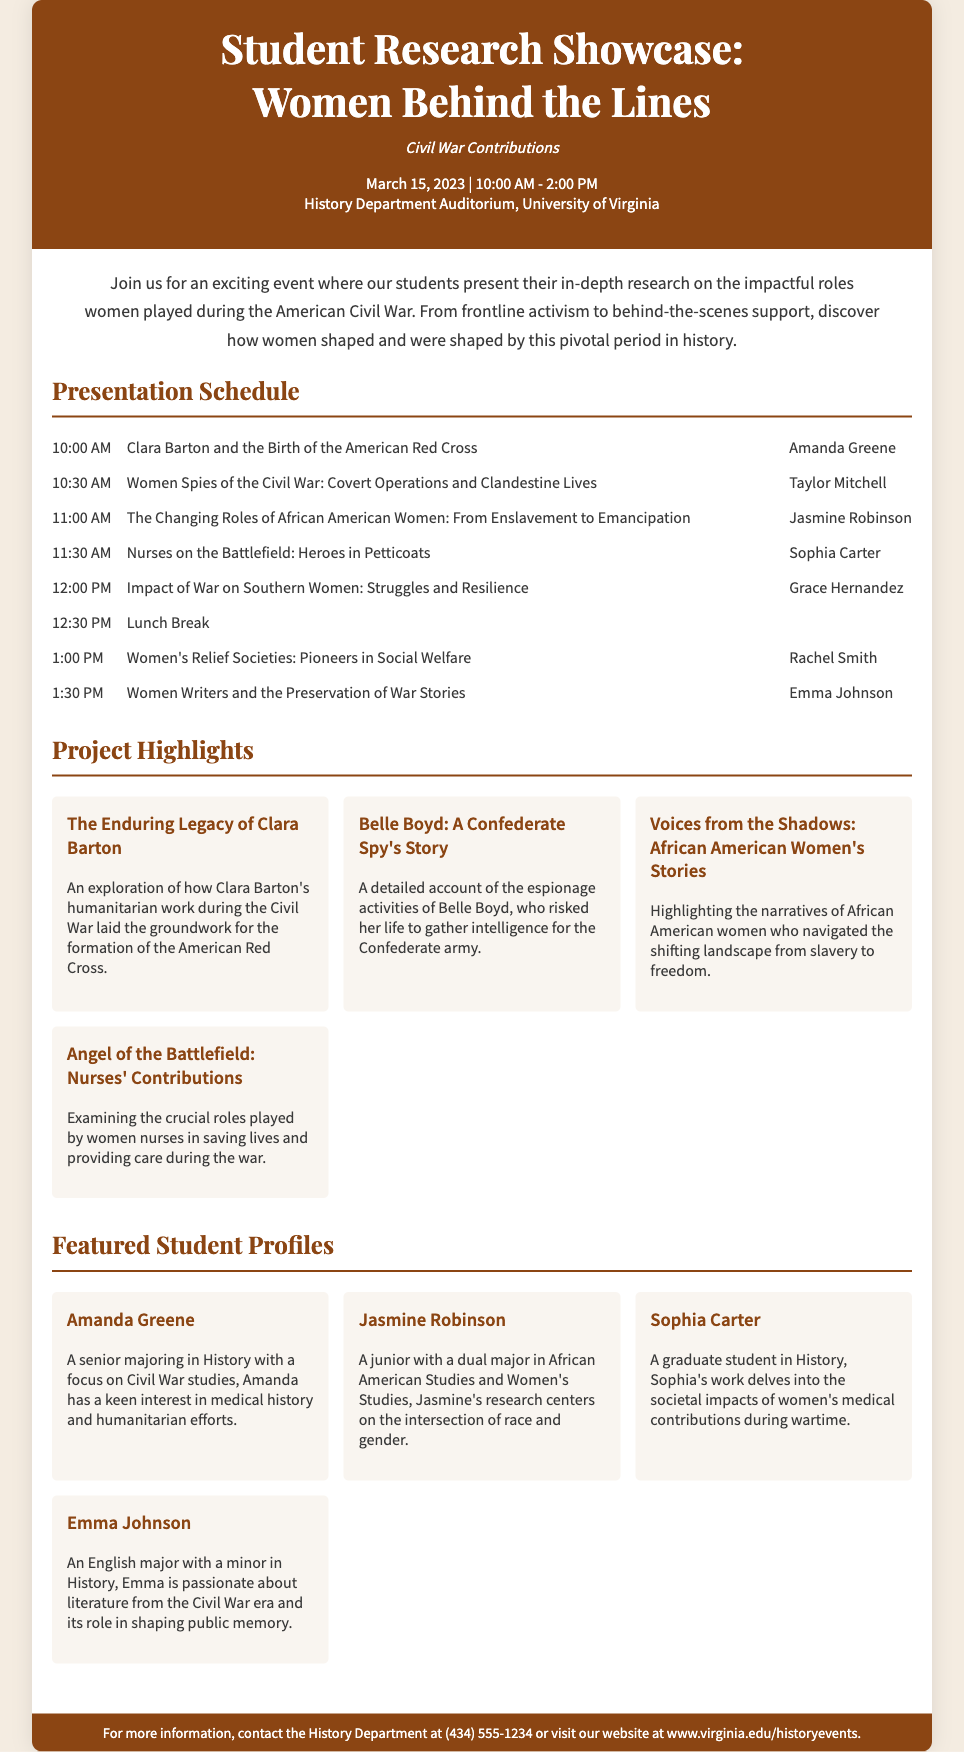What is the title of the event? The title of the event is prominently displayed at the top of the flyer.
Answer: Student Research Showcase: Women Behind the Lines What date is the event scheduled for? The date of the event is mentioned in the event details.
Answer: March 15, 2023 Who is presenting on "Women Spies of the Civil War"? The presenter's name is listed alongside the project title in the schedule section.
Answer: Taylor Mitchell What time does the lunch break start? The lunch break time is part of the presentation schedule.
Answer: 12:30 PM Which student is a junior with a dual major? The student profiles include educational background information.
Answer: Jasmine Robinson How many project highlights are listed? The number of project highlights can be counted from the projects section of the flyer.
Answer: Four What role did Clara Barton play during the Civil War? The flyer describes Clara Barton's contributions in the project highlights.
Answer: Humanitarian work What department is hosting the event? The department hosting the event is mentioned in the footer of the flyer.
Answer: History Department 